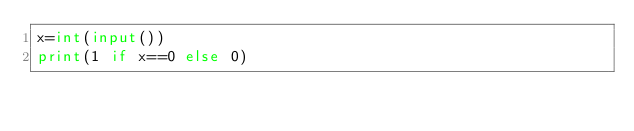<code> <loc_0><loc_0><loc_500><loc_500><_Python_>x=int(input())
print(1 if x==0 else 0)</code> 